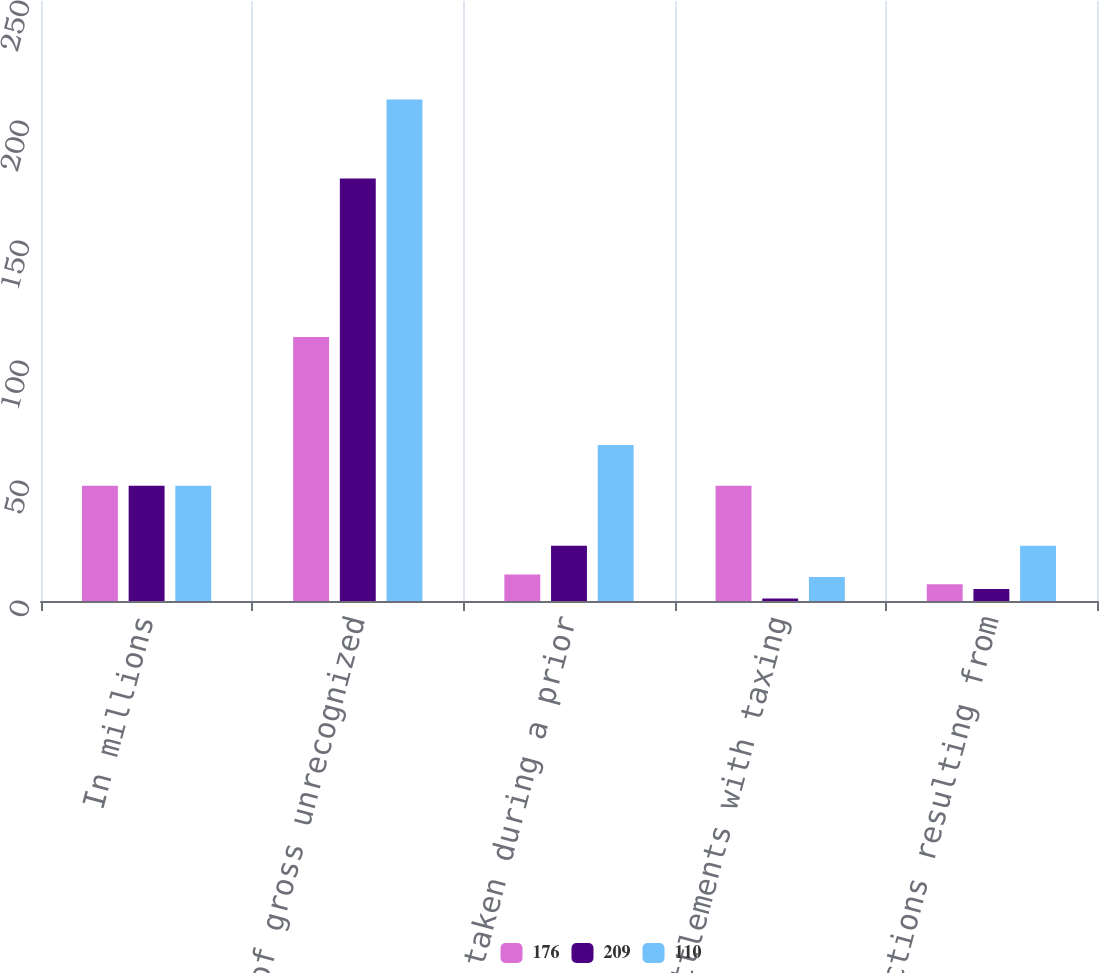Convert chart to OTSL. <chart><loc_0><loc_0><loc_500><loc_500><stacked_bar_chart><ecel><fcel>In millions<fcel>Balance of gross unrecognized<fcel>Positions taken during a prior<fcel>Settlements with taxing<fcel>Reductions resulting from<nl><fcel>176<fcel>48<fcel>110<fcel>11<fcel>48<fcel>7<nl><fcel>209<fcel>48<fcel>176<fcel>23<fcel>1<fcel>5<nl><fcel>110<fcel>48<fcel>209<fcel>65<fcel>10<fcel>23<nl></chart> 